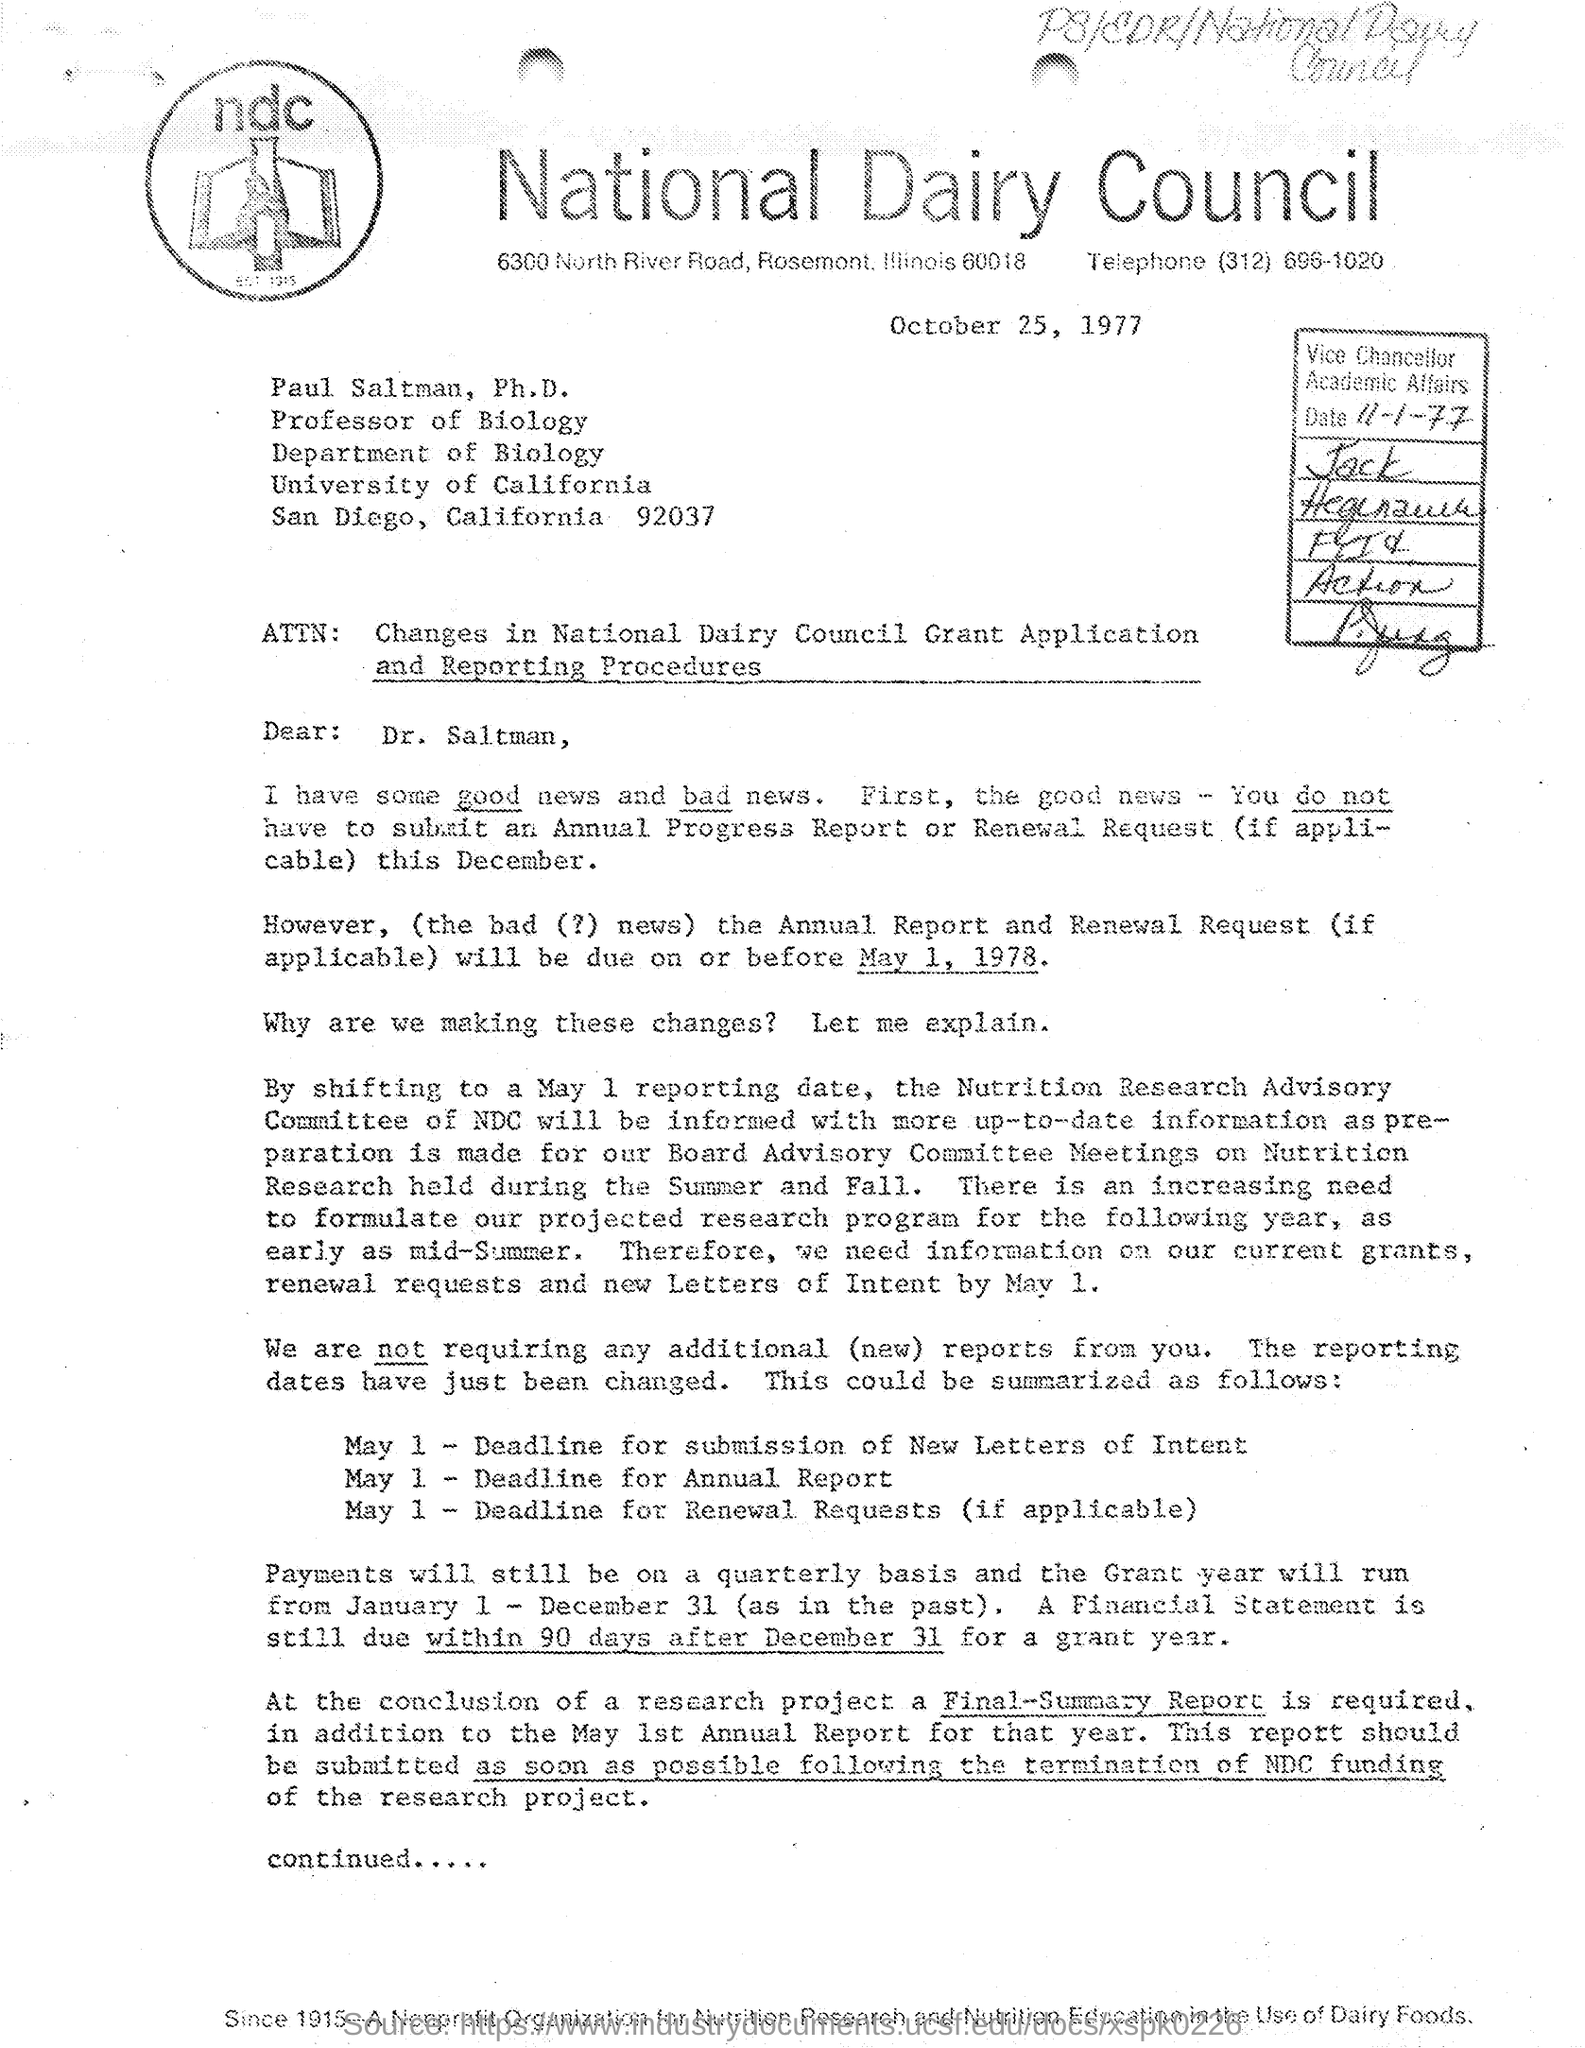What is the full form of NDC?
Keep it short and to the point. National Dairy Council. What is the date written on the Application?
Your answer should be compact. October 25, 1977. What is the Phone No. of the Application?
Keep it short and to the point. (312) 696-1020. 